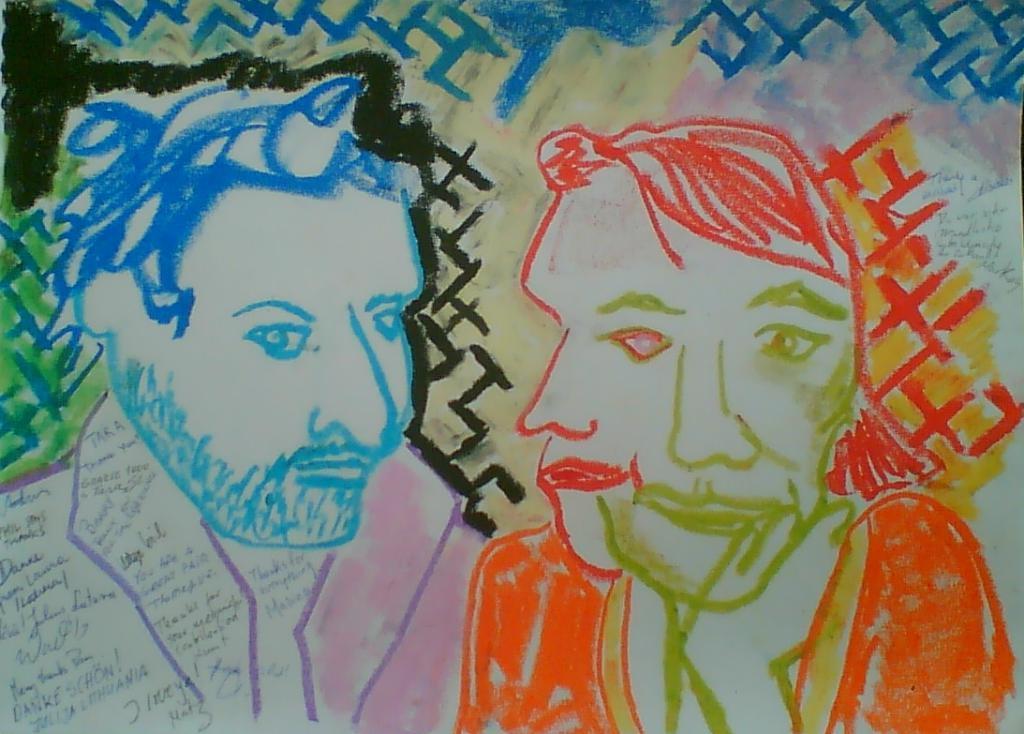Could you give a brief overview of what you see in this image? There are some drawings on the paper,the images of people are drawn on a paper using crayons. 